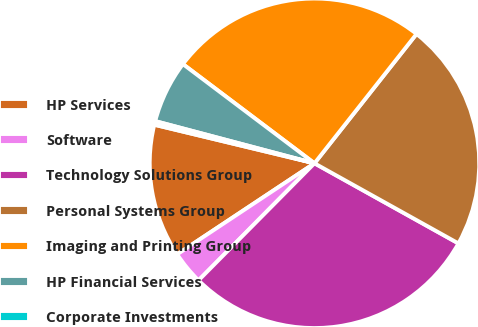Convert chart. <chart><loc_0><loc_0><loc_500><loc_500><pie_chart><fcel>HP Services<fcel>Software<fcel>Technology Solutions Group<fcel>Personal Systems Group<fcel>Imaging and Printing Group<fcel>HP Financial Services<fcel>Corporate Investments<nl><fcel>13.08%<fcel>3.26%<fcel>29.34%<fcel>22.45%<fcel>25.35%<fcel>6.16%<fcel>0.36%<nl></chart> 